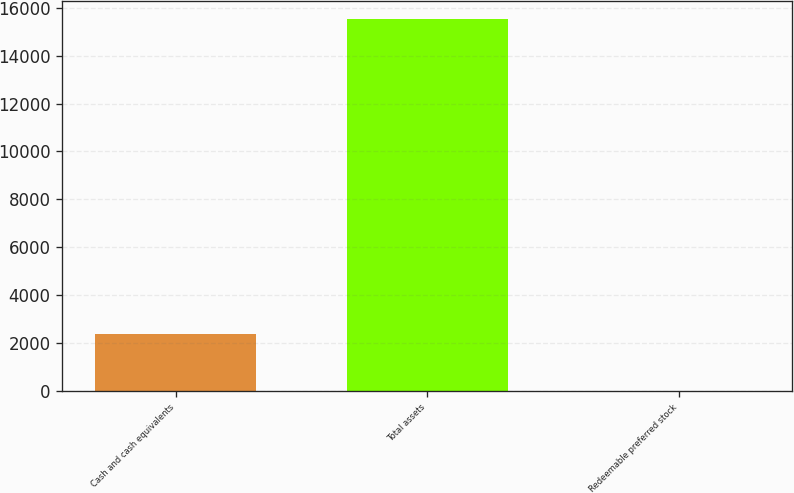Convert chart. <chart><loc_0><loc_0><loc_500><loc_500><bar_chart><fcel>Cash and cash equivalents<fcel>Total assets<fcel>Redeemable preferred stock<nl><fcel>2381<fcel>15523<fcel>20<nl></chart> 